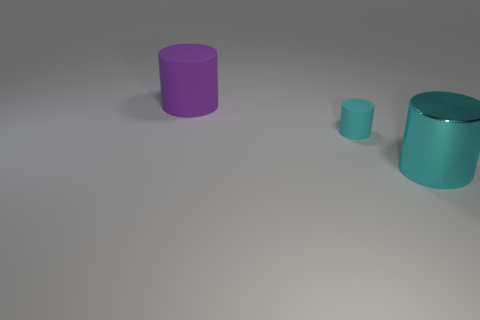Are there any other things that have the same size as the cyan rubber cylinder?
Your response must be concise. No. What number of rubber objects are small cyan objects or large cylinders?
Your response must be concise. 2. There is a metallic cylinder that is on the right side of the matte object that is left of the cyan matte cylinder; what is its size?
Provide a short and direct response. Large. There is a small cylinder that is the same color as the large metal cylinder; what is its material?
Provide a short and direct response. Rubber. Is there a large cylinder that is on the right side of the cylinder that is behind the rubber object on the right side of the big purple matte cylinder?
Provide a succinct answer. Yes. Are the purple thing that is left of the large cyan metal cylinder and the cyan cylinder that is left of the metallic object made of the same material?
Make the answer very short. Yes. What number of objects are either purple objects or things in front of the big purple thing?
Ensure brevity in your answer.  3. How many large purple things are the same shape as the cyan rubber object?
Offer a terse response. 1. What is the material of the cyan object that is the same size as the purple matte cylinder?
Give a very brief answer. Metal. What is the size of the matte cylinder that is right of the large thing that is left of the large cylinder that is in front of the purple cylinder?
Give a very brief answer. Small. 